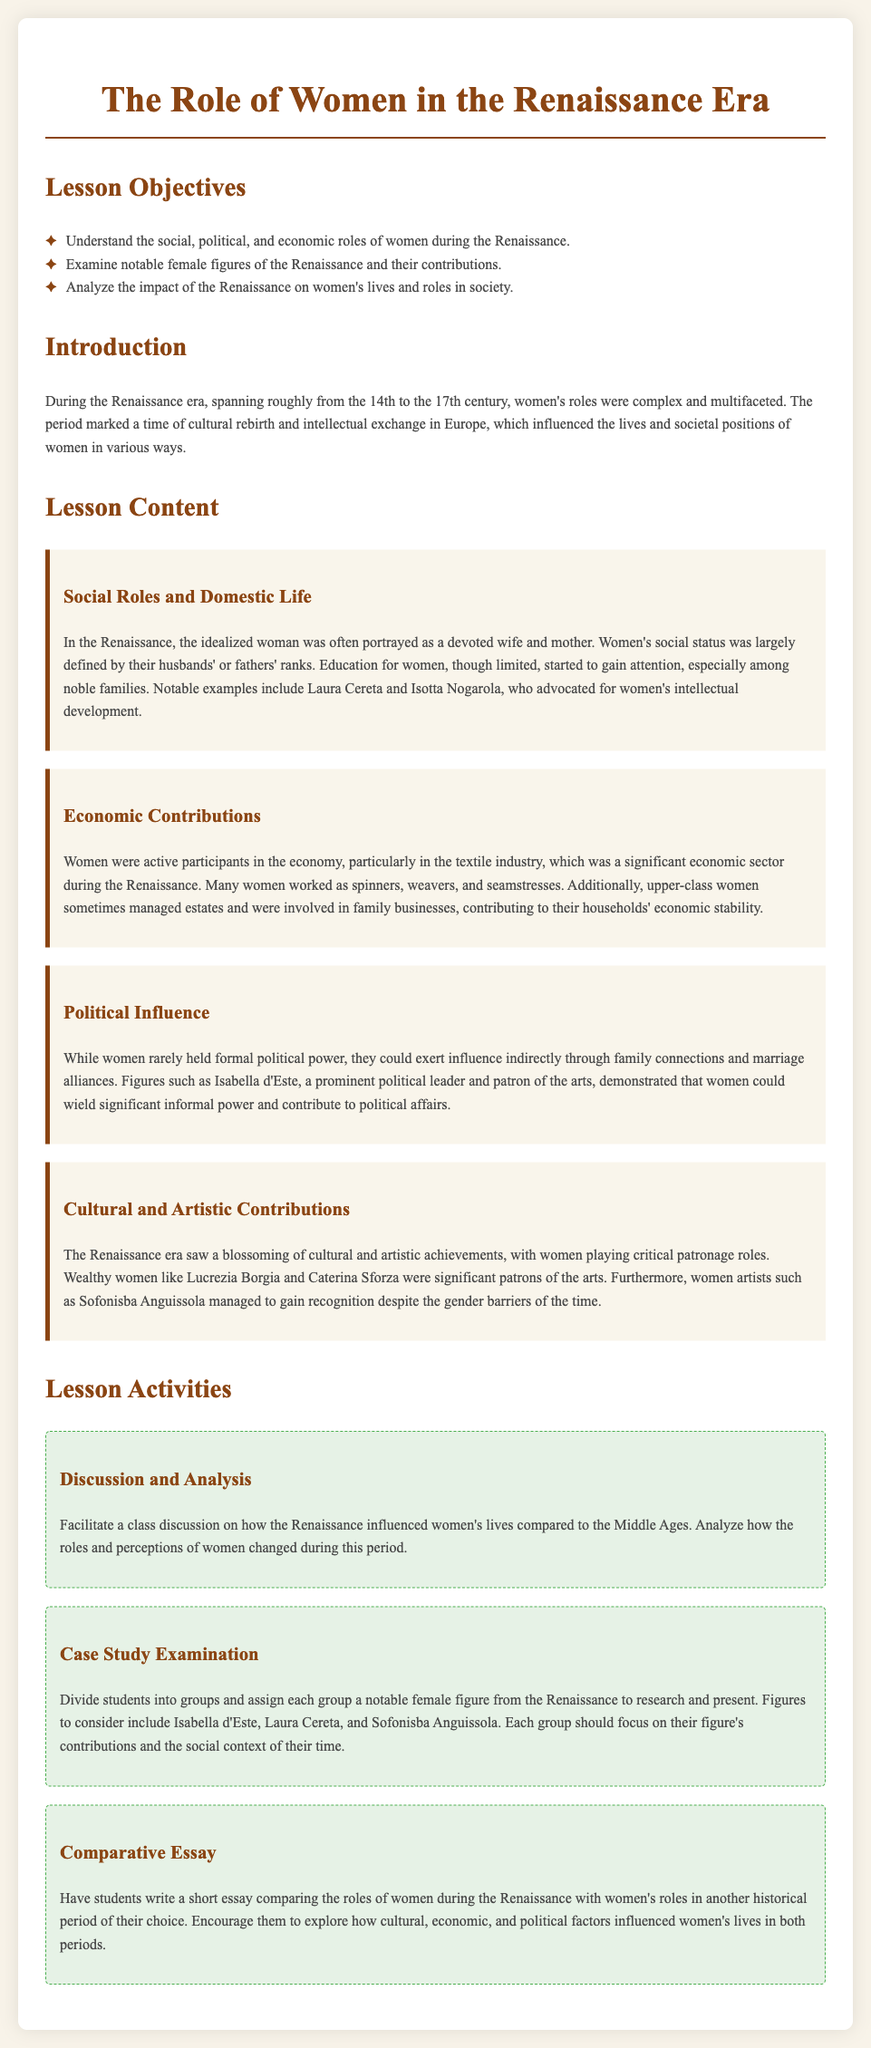What are the lesson objectives? The lesson objectives include understanding women's roles during the Renaissance, examining notable female figures, and analyzing the impact of the Renaissance on women's lives.
Answer: Understand the social, political, and economic roles of women during the Renaissance Who were the notable figures mentioned in the lesson plan? The lesson plan identifies Isabella d'Este, Laura Cereta, Sofonisba Anguissola, Lucrezia Borgia, and Caterina Sforza as notable figures.
Answer: Isabella d'Este, Laura Cereta, and Sofonisba Anguissola What was a common economic role for women in the Renaissance? The document states that women were active participants in the textile industry, which was significant during this period.
Answer: Textile industry What type of activities are included in the lesson plan? The document outlines several activities including discussions, case study examinations, and comparative essays.
Answer: Discussion and Analysis What is one way women could exert political influence during the Renaissance? Women could exert influence indirectly through family connections and marriage alliances.
Answer: Family connections and marriage alliances When did the Renaissance era take place? The document states that the Renaissance era spanned roughly from the 14th to the 17th century.
Answer: 14th to 17th century What role did women play in cultural and artistic achievements? The lesson plan highlights that women played critical patronage roles and that women artists gained recognition despite barriers.
Answer: Critical patronage roles How are the lesson activities structured? The lesson activities are structured to include group research presentations and essay writing.
Answer: Group research presentations and essay writing 